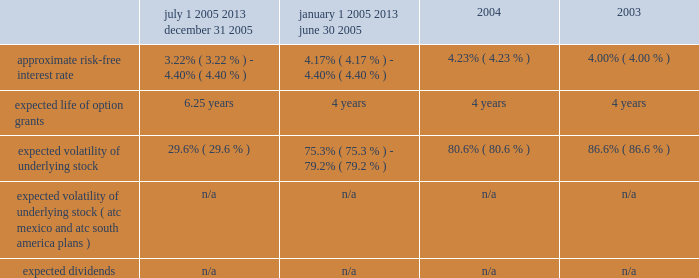American tower corporation and subsidiaries notes to consolidated financial statements 2014 ( continued ) 2003 were $ 10.08 , $ 7.05 , and $ 6.32 per share , respectively .
Key assumptions used to apply this pricing model are as follows : july 1 , 2005 2013 december 31 , 2005 january 1 , 2005 2013 june 30 , 2005 2004 2003 .
Voluntary option exchanges 2014in february 2004 , the company issued to eligible employees 1032717 options with an exercise price of $ 11.19 per share , the fair market value of the class a common stock on the date of grant .
These options were issued in connection with a voluntary option exchange program entered into by the company in august 2003 , pursuant to which the company accepted for surrender and cancelled options to purchase a total of 1831981 shares of its class a common stock having an exercise price of $ 10.25 or greater .
The program , which was offered to both full and part-time employees , excluding the company 2019s executive officers and its directors , provided for the grant ( at least six months and one day from the surrender date to employees still employed on that date ) of new options exercisable for two shares of class a common stock for every three shares of class a common stock issuable upon exercise of a surrendered option .
No options were granted to any employees who participated in the exchange offer between the cancellation date and the new grant atc mexico stock option plan 2014the company maintains a stock option plan in its atc mexico subsidiary ( atc mexico plan ) .
The atc mexico plan provides for the issuance of options to officers , employees , directors and consultants of atc mexico .
The atc mexico plan limits the number of shares of common stock which may be granted to an aggregate of 360 shares , subject to adjustment based on changes in atc mexico 2019s capital structure .
During 2002 , atc mexico granted options to purchase 318 shares of atc mexico common stock to officers and employees .
Such options were issued at one time with an exercise price of $ 10000 per share .
The exercise price per share was at fair market value as determined by the board of directors with the assistance of an independent appraisal performed at the company 2019s request .
The fair value of atc mexico plan options granted during 2002 were $ 3611 per share as determined by using the black-scholes option pricing model .
As described in note 11 , all outstanding options were exercised in march 2004 .
No options under the atc mexico plan were outstanding as of december 31 , 2005 .
( see note 11. ) atc south america stock option plan 2014the company maintains a stock option plan in its atc south america subsidiary ( atc south america plan ) .
The atc south america plan provides for the issuance of options to officers , employees , directors and consultants of atc south america .
The atc south america plan limits the number of shares of common stock which may be granted to an aggregate of 6144 shares , ( an approximate 10.3% ( 10.3 % ) interest on a fully-diluted basis ) , subject to adjustment based on changes in atc south america 2019s capital structure .
During 2004 , atc south america granted options to purchase 6024 shares of atc south america common stock to officers and employees , including messrs .
Gearon and hess , who received options to purchase an approximate 6.7% ( 6.7 % ) and 1.6% ( 1.6 % ) interest , respectively .
Such options were issued at one time with an exercise price of $ 1349 per share .
The exercise price per share was at fair market value on the date of issuance as determined by the board of directors with the assistance of an independent appraisal performed at the company 2019s request .
The fair value of atc south america plan options granted during 2004 were $ 79 per share as determined by using the black-scholes option pricing model .
Options granted vest upon the earlier to occur of ( a ) the exercise by or on behalf of mr .
Gearon of his right to sell his interest in atc south america to the company , ( b ) the .
What are the total proceeds from the issuance of employee options during february 2004 , in millions? 
Computations: ((1032717 * 11.19) / 1000000)
Answer: 11.5561. 